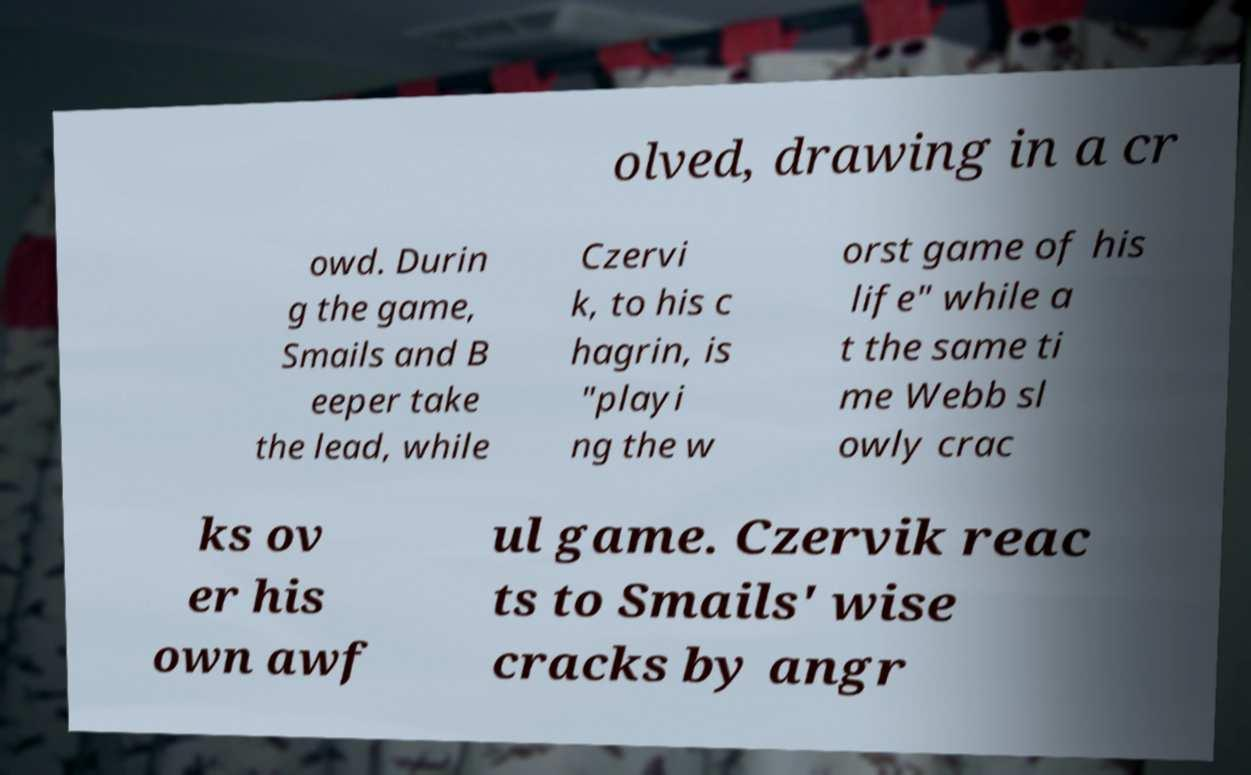For documentation purposes, I need the text within this image transcribed. Could you provide that? olved, drawing in a cr owd. Durin g the game, Smails and B eeper take the lead, while Czervi k, to his c hagrin, is "playi ng the w orst game of his life" while a t the same ti me Webb sl owly crac ks ov er his own awf ul game. Czervik reac ts to Smails' wise cracks by angr 